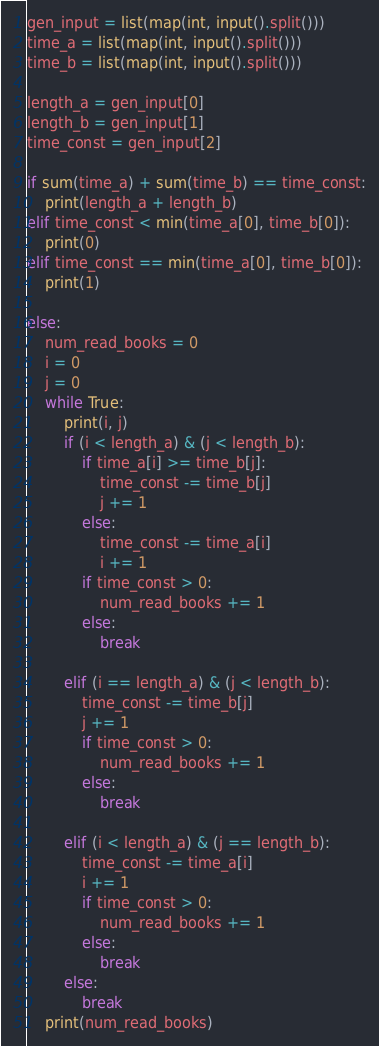<code> <loc_0><loc_0><loc_500><loc_500><_Python_>gen_input = list(map(int, input().split()))
time_a = list(map(int, input().split()))
time_b = list(map(int, input().split()))

length_a = gen_input[0]
length_b = gen_input[1]
time_const = gen_input[2]

if sum(time_a) + sum(time_b) == time_const:
    print(length_a + length_b)
elif time_const < min(time_a[0], time_b[0]):
    print(0)
elif time_const == min(time_a[0], time_b[0]):
    print(1)

else:
    num_read_books = 0
    i = 0
    j = 0
    while True:
        print(i, j)
        if (i < length_a) & (j < length_b):
            if time_a[i] >= time_b[j]:
                time_const -= time_b[j]
                j += 1
            else:
                time_const -= time_a[i]
                i += 1
            if time_const > 0:
                num_read_books += 1
            else:
                break
        
        elif (i == length_a) & (j < length_b):
            time_const -= time_b[j]
            j += 1
            if time_const > 0:
                num_read_books += 1
            else:
                break

        elif (i < length_a) & (j == length_b):
            time_const -= time_a[i]
            i += 1
            if time_const > 0:
                num_read_books += 1
            else:
                break
        else:
            break
    print(num_read_books)</code> 